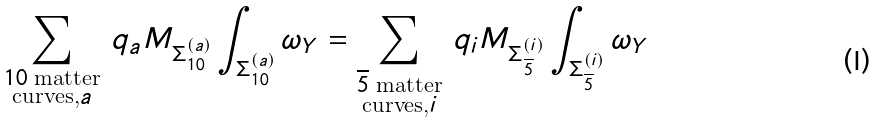<formula> <loc_0><loc_0><loc_500><loc_500>\sum _ { \substack { 1 0 \text { matter} \\ \text {curves,} a } } \, q _ { a } M _ { \Sigma _ { 1 0 } ^ { ( a ) } } \int _ { \Sigma _ { 1 0 } ^ { ( a ) } } \omega _ { Y } = \sum _ { \substack { \overline { 5 } \text { matter} \\ \text {curves,} i } } \, q _ { i } M _ { \Sigma _ { \overline { 5 } } ^ { ( i ) } } \int _ { \Sigma _ { \overline { 5 } } ^ { ( i ) } } \omega _ { Y }</formula> 